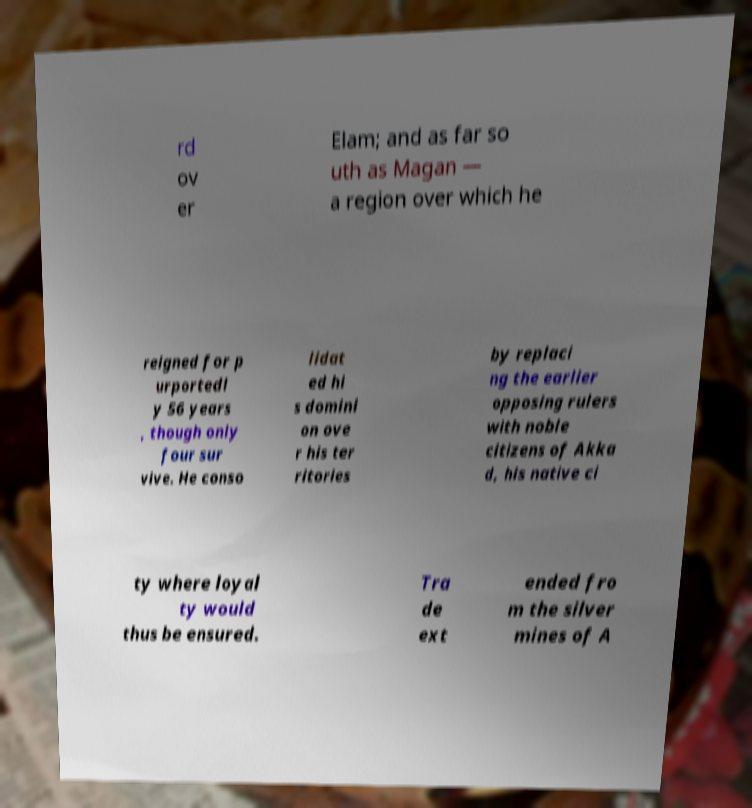I need the written content from this picture converted into text. Can you do that? rd ov er Elam; and as far so uth as Magan — a region over which he reigned for p urportedl y 56 years , though only four sur vive. He conso lidat ed hi s domini on ove r his ter ritories by replaci ng the earlier opposing rulers with noble citizens of Akka d, his native ci ty where loyal ty would thus be ensured. Tra de ext ended fro m the silver mines of A 